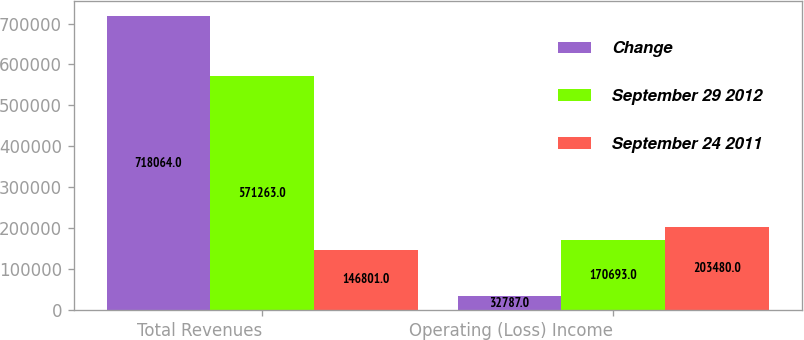<chart> <loc_0><loc_0><loc_500><loc_500><stacked_bar_chart><ecel><fcel>Total Revenues<fcel>Operating (Loss) Income<nl><fcel>Change<fcel>718064<fcel>32787<nl><fcel>September 29 2012<fcel>571263<fcel>170693<nl><fcel>September 24 2011<fcel>146801<fcel>203480<nl></chart> 